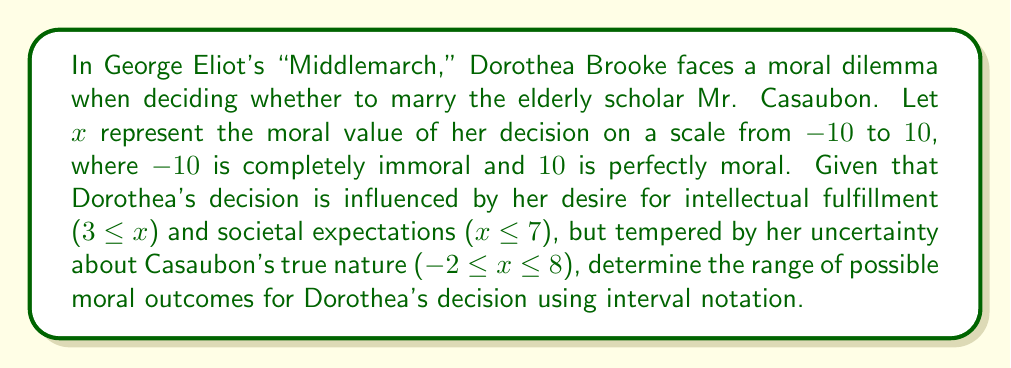Could you help me with this problem? To solve this problem, we need to consider all the given constraints and find their intersection:

1. Desire for intellectual fulfillment: $3 \leq x$
2. Societal expectations: $x \leq 7$
3. Uncertainty about Casaubon's nature: $-2 \leq x \leq 8$

Let's combine these constraints:

1. The lower bound is the maximum of the lower bounds: $\max(-2, 3) = 3$
2. The upper bound is the minimum of the upper bounds: $\min(7, 8) = 7$

Therefore, the range of possible moral outcomes is $3 \leq x \leq 7$.

In interval notation, this is written as $[3, 7]$.

This result suggests that Dorothea's decision to marry Mr. Casaubon could range from slightly positive (3) to moderately positive (7) on the moral scale, reflecting the complex interplay of personal aspirations, societal norms, and uncertainty in Victorian-era moral dilemmas.
Answer: $[3, 7]$ 